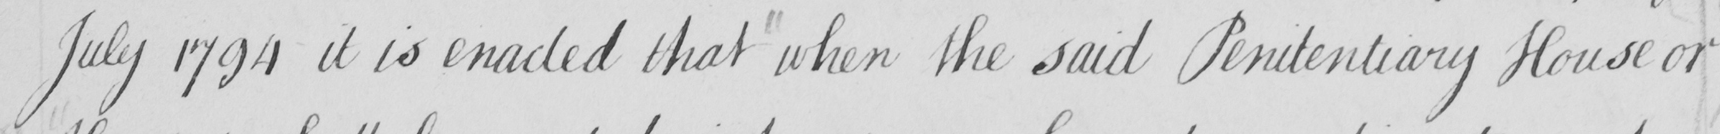What is written in this line of handwriting? July 1794 it is enacted that when the said Penitentiary House or 